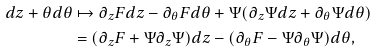Convert formula to latex. <formula><loc_0><loc_0><loc_500><loc_500>d z + \theta d \theta & \mapsto \partial _ { z } F d z - \partial _ { \theta } F d \theta + \Psi ( \partial _ { z } \Psi d z + \partial _ { \theta } \Psi d \theta ) \\ & = ( \partial _ { z } F + \Psi \partial _ { z } \Psi ) d z - ( \partial _ { \theta } F - \Psi \partial _ { \theta } \Psi ) d \theta ,</formula> 